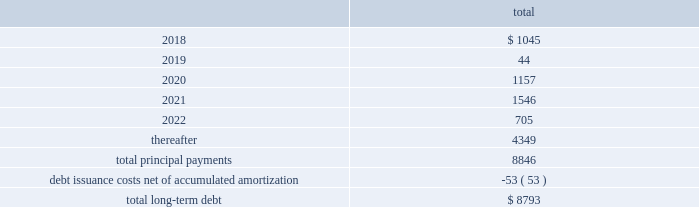Fidelity national information services , inc .
And subsidiaries notes to consolidated financial statements - ( continued ) the following summarizes the aggregate maturities of our debt and capital leases on stated contractual maturities , excluding unamortized non-cash bond premiums and discounts net of $ 30 million as of december 31 , 2017 ( in millions ) : .
There are no mandatory principal payments on the revolving loan and any balance outstanding on the revolving loan will be due and payable at its scheduled maturity date , which occurs at august 10 , 2021 .
Fis may redeem the 2018 notes , 2020 notes , 2021 notes , 2021 euro notes , 2022 notes , 2022 gbp notes , 2023 notes , 2024 notes , 2024 euro notes , 2025 notes , 2026 notes , and 2046 notes at its option in whole or in part , at any time and from time to time , at a redemption price equal to the greater of 100% ( 100 % ) of the principal amount to be redeemed and a make-whole amount calculated as described in the related indenture in each case plus accrued and unpaid interest to , but excluding , the date of redemption , provided no make-whole amount will be paid for redemptions of the 2020 notes , the 2021 notes , the 2021 euro notes and the 2022 gbp notes during the one month prior to their maturity , the 2022 notes during the two months prior to their maturity , the 2023 notes , the 2024 notes , the 2024 euro notes , the 2025 notes , and the 2026 notes during the three months prior to their maturity , and the 2046 notes during the six months prior to their maturity .
Debt issuance costs of $ 53 million , net of accumulated amortization , remain capitalized as of december 31 , 2017 , related to all of the above outstanding debt .
We monitor the financial stability of our counterparties on an ongoing basis .
The lender commitments under the undrawn portions of the revolving loan are comprised of a diversified set of financial institutions , both domestic and international .
The failure of any single lender to perform its obligations under the revolving loan would not adversely impact our ability to fund operations .
The fair value of the company 2019s long-term debt is estimated to be approximately $ 156 million higher than the carrying value as of december 31 , 2017 .
This estimate is based on quoted prices of our senior notes and trades of our other debt in close proximity to december 31 , 2017 , which are considered level 2-type measurements .
This estimate is subjective in nature and involves uncertainties and significant judgment in the interpretation of current market data .
Therefore , the values presented are not necessarily indicative of amounts the company could realize or settle currently. .
What percent of total long-term debt is due in 2021? 
Computations: (1546 / 8793)
Answer: 0.17582. Fidelity national information services , inc .
And subsidiaries notes to consolidated financial statements - ( continued ) the following summarizes the aggregate maturities of our debt and capital leases on stated contractual maturities , excluding unamortized non-cash bond premiums and discounts net of $ 30 million as of december 31 , 2017 ( in millions ) : .
There are no mandatory principal payments on the revolving loan and any balance outstanding on the revolving loan will be due and payable at its scheduled maturity date , which occurs at august 10 , 2021 .
Fis may redeem the 2018 notes , 2020 notes , 2021 notes , 2021 euro notes , 2022 notes , 2022 gbp notes , 2023 notes , 2024 notes , 2024 euro notes , 2025 notes , 2026 notes , and 2046 notes at its option in whole or in part , at any time and from time to time , at a redemption price equal to the greater of 100% ( 100 % ) of the principal amount to be redeemed and a make-whole amount calculated as described in the related indenture in each case plus accrued and unpaid interest to , but excluding , the date of redemption , provided no make-whole amount will be paid for redemptions of the 2020 notes , the 2021 notes , the 2021 euro notes and the 2022 gbp notes during the one month prior to their maturity , the 2022 notes during the two months prior to their maturity , the 2023 notes , the 2024 notes , the 2024 euro notes , the 2025 notes , and the 2026 notes during the three months prior to their maturity , and the 2046 notes during the six months prior to their maturity .
Debt issuance costs of $ 53 million , net of accumulated amortization , remain capitalized as of december 31 , 2017 , related to all of the above outstanding debt .
We monitor the financial stability of our counterparties on an ongoing basis .
The lender commitments under the undrawn portions of the revolving loan are comprised of a diversified set of financial institutions , both domestic and international .
The failure of any single lender to perform its obligations under the revolving loan would not adversely impact our ability to fund operations .
The fair value of the company 2019s long-term debt is estimated to be approximately $ 156 million higher than the carrying value as of december 31 , 2017 .
This estimate is based on quoted prices of our senior notes and trades of our other debt in close proximity to december 31 , 2017 , which are considered level 2-type measurements .
This estimate is subjective in nature and involves uncertainties and significant judgment in the interpretation of current market data .
Therefore , the values presented are not necessarily indicative of amounts the company could realize or settle currently. .
What percent of total long-term debt is due after 2022? 
Computations: (4349 / 8793)
Answer: 0.4946. 